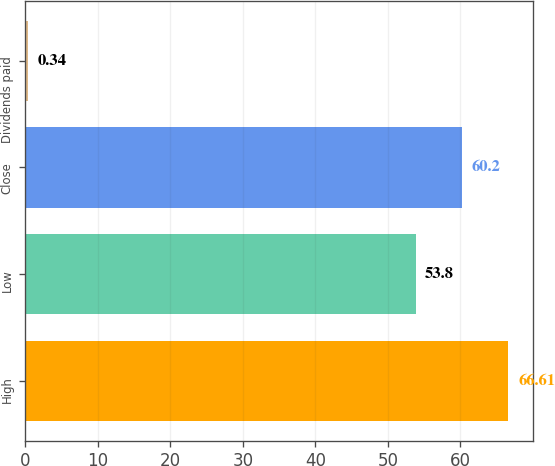<chart> <loc_0><loc_0><loc_500><loc_500><bar_chart><fcel>High<fcel>Low<fcel>Close<fcel>Dividends paid<nl><fcel>66.61<fcel>53.8<fcel>60.2<fcel>0.34<nl></chart> 